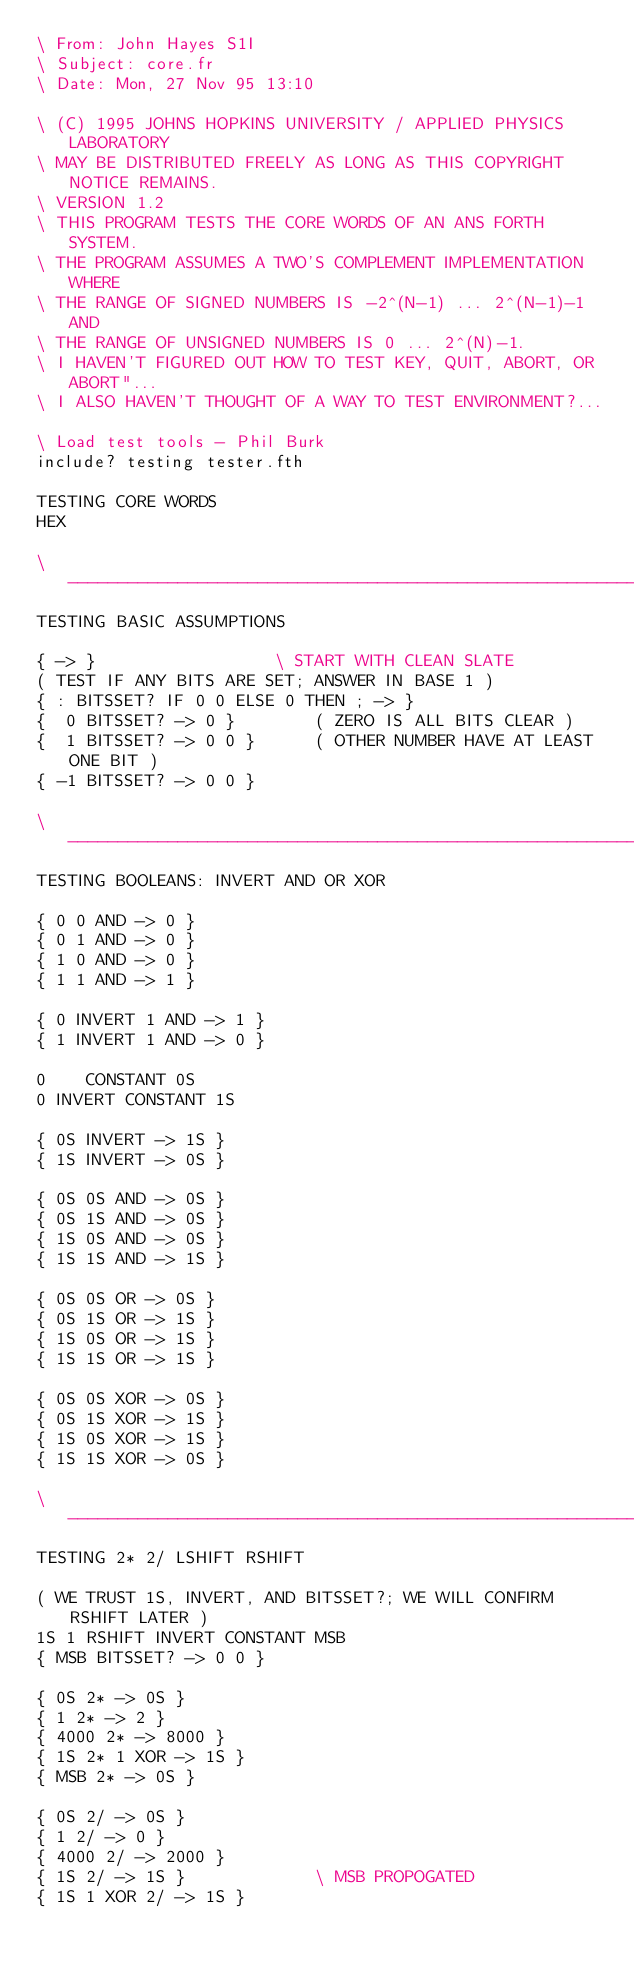<code> <loc_0><loc_0><loc_500><loc_500><_Forth_>\ From: John Hayes S1I
\ Subject: core.fr
\ Date: Mon, 27 Nov 95 13:10

\ (C) 1995 JOHNS HOPKINS UNIVERSITY / APPLIED PHYSICS LABORATORY
\ MAY BE DISTRIBUTED FREELY AS LONG AS THIS COPYRIGHT NOTICE REMAINS.
\ VERSION 1.2
\ THIS PROGRAM TESTS THE CORE WORDS OF AN ANS FORTH SYSTEM.
\ THE PROGRAM ASSUMES A TWO'S COMPLEMENT IMPLEMENTATION WHERE
\ THE RANGE OF SIGNED NUMBERS IS -2^(N-1) ... 2^(N-1)-1 AND
\ THE RANGE OF UNSIGNED NUMBERS IS 0 ... 2^(N)-1.
\ I HAVEN'T FIGURED OUT HOW TO TEST KEY, QUIT, ABORT, OR ABORT"...
\ I ALSO HAVEN'T THOUGHT OF A WAY TO TEST ENVIRONMENT?...

\ Load test tools - Phil Burk
include? testing tester.fth

TESTING CORE WORDS
HEX

\ ------------------------------------------------------------------------
TESTING BASIC ASSUMPTIONS

{ -> }					\ START WITH CLEAN SLATE
( TEST IF ANY BITS ARE SET; ANSWER IN BASE 1 )
{ : BITSSET? IF 0 0 ELSE 0 THEN ; -> }
{  0 BITSSET? -> 0 }		( ZERO IS ALL BITS CLEAR )
{  1 BITSSET? -> 0 0 }		( OTHER NUMBER HAVE AT LEAST ONE BIT )
{ -1 BITSSET? -> 0 0 }

\ ------------------------------------------------------------------------
TESTING BOOLEANS: INVERT AND OR XOR

{ 0 0 AND -> 0 }
{ 0 1 AND -> 0 }
{ 1 0 AND -> 0 }
{ 1 1 AND -> 1 }

{ 0 INVERT 1 AND -> 1 }
{ 1 INVERT 1 AND -> 0 }

0	 CONSTANT 0S
0 INVERT CONSTANT 1S

{ 0S INVERT -> 1S }
{ 1S INVERT -> 0S }

{ 0S 0S AND -> 0S }
{ 0S 1S AND -> 0S }
{ 1S 0S AND -> 0S }
{ 1S 1S AND -> 1S }

{ 0S 0S OR -> 0S }
{ 0S 1S OR -> 1S }
{ 1S 0S OR -> 1S }
{ 1S 1S OR -> 1S }

{ 0S 0S XOR -> 0S }
{ 0S 1S XOR -> 1S }
{ 1S 0S XOR -> 1S }
{ 1S 1S XOR -> 0S }

\ ------------------------------------------------------------------------
TESTING 2* 2/ LSHIFT RSHIFT

( WE TRUST 1S, INVERT, AND BITSSET?; WE WILL CONFIRM RSHIFT LATER )
1S 1 RSHIFT INVERT CONSTANT MSB
{ MSB BITSSET? -> 0 0 }

{ 0S 2* -> 0S }
{ 1 2* -> 2 }
{ 4000 2* -> 8000 }
{ 1S 2* 1 XOR -> 1S }
{ MSB 2* -> 0S }

{ 0S 2/ -> 0S }
{ 1 2/ -> 0 }
{ 4000 2/ -> 2000 }
{ 1S 2/ -> 1S }				\ MSB PROPOGATED
{ 1S 1 XOR 2/ -> 1S }</code> 